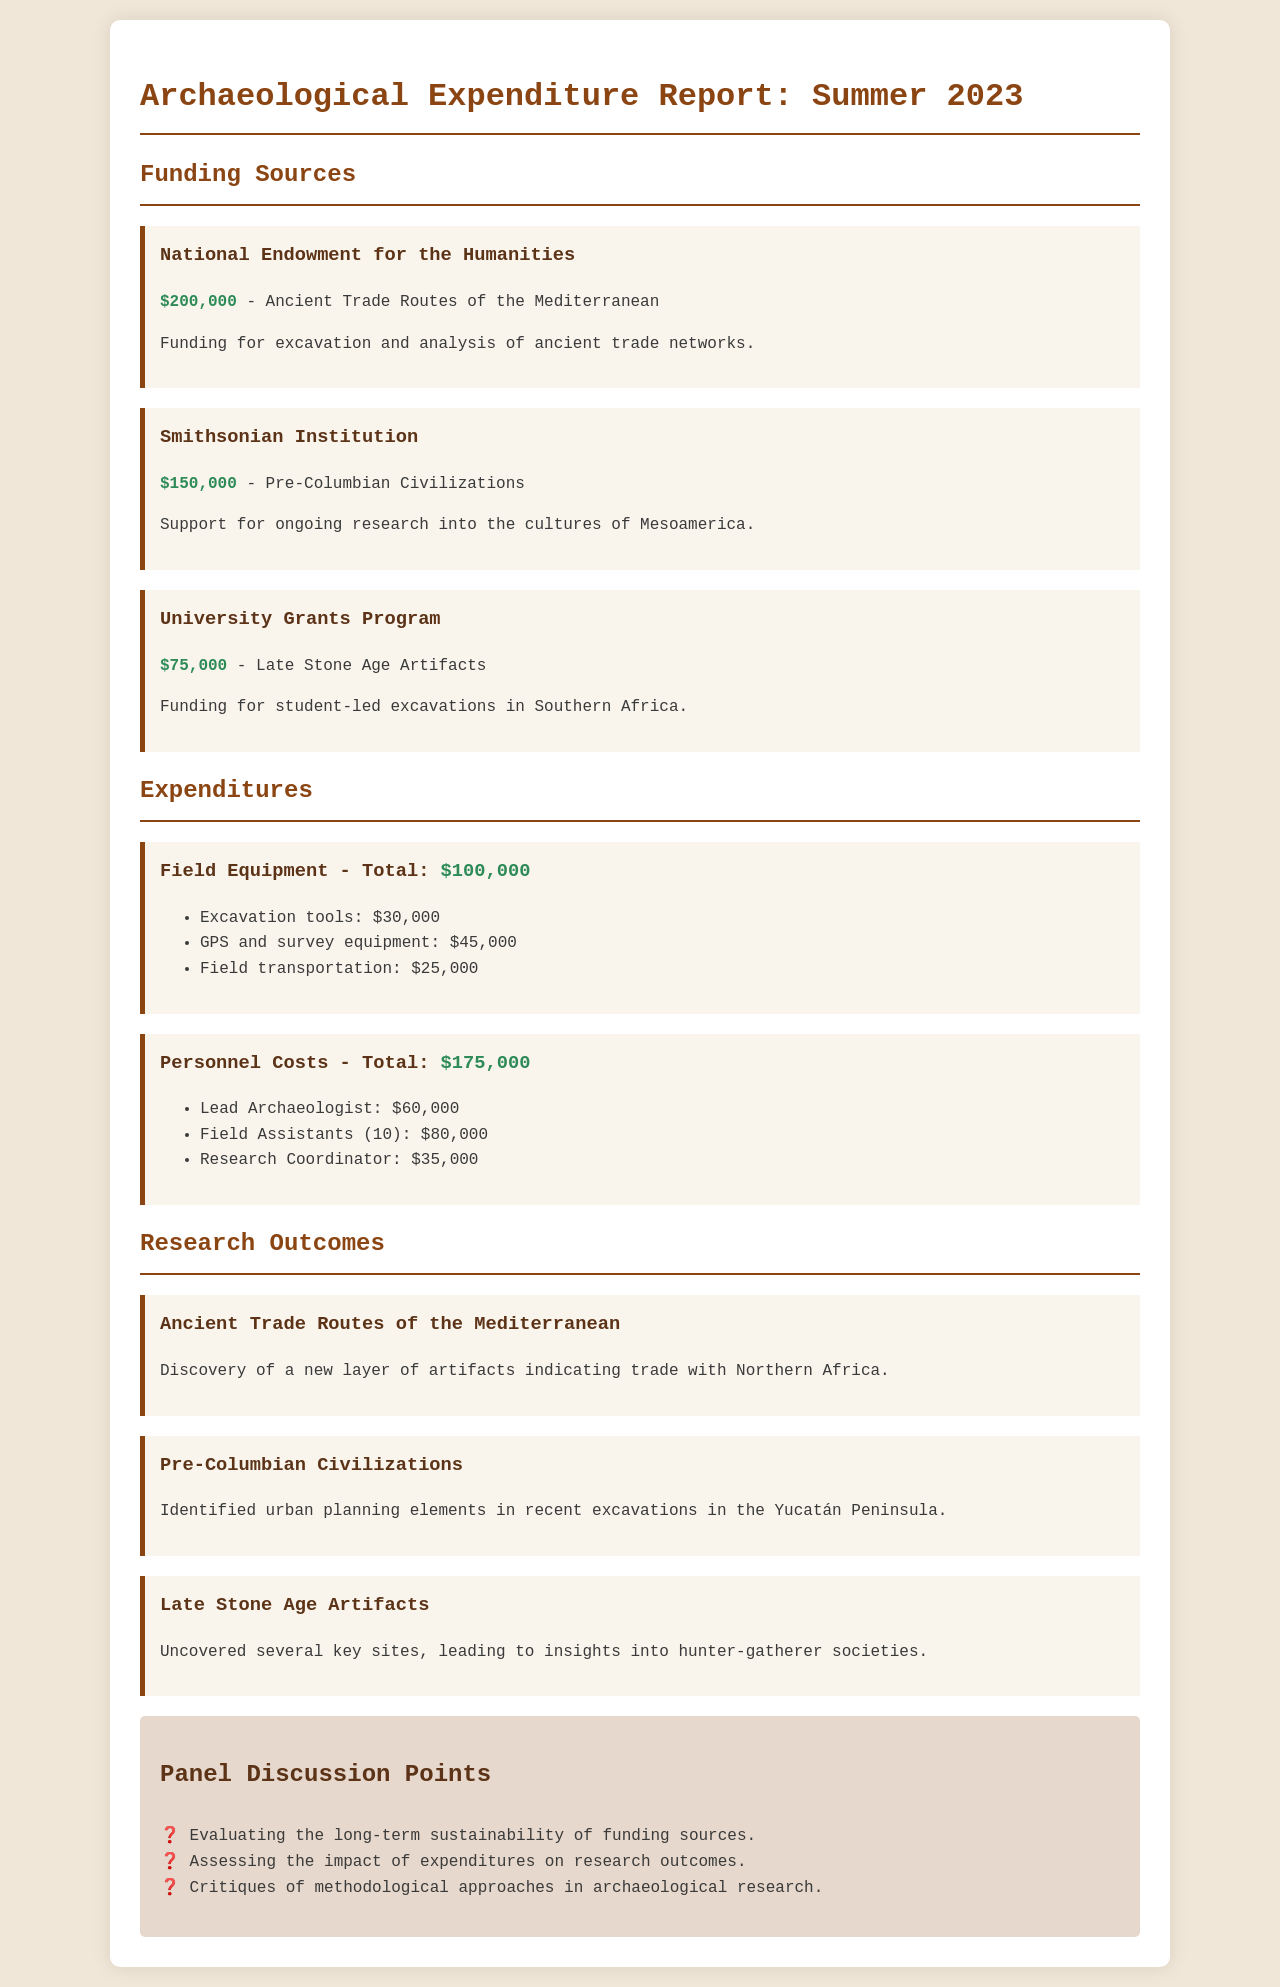What is the total funding from the National Endowment for the Humanities? The funding amount specified for the National Endowment for the Humanities is $200,000.
Answer: $200,000 How much was allocated for field equipment? The total allocated for field equipment is detailed in the expenditures section as $100,000.
Answer: $100,000 What project received funding from the Smithsonian Institution? The project titled "Pre-Columbian Civilizations" received funding from the Smithsonian Institution.
Answer: Pre-Columbian Civilizations What is the total expense for personnel costs? The total expense for personnel costs is specifically listed as $175,000 in the expenditures section.
Answer: $175,000 How many field assistants were employed? The document states that there were 10 field assistants employed, as mentioned under personnel costs.
Answer: 10 What key finding was reported in the "Ancient Trade Routes of the Mediterranean" project? The key finding reported indicates the discovery of a new layer of artifacts indicating trade with Northern Africa.
Answer: Trade with Northern Africa What is one of the panel discussion points mentioned? The document lists "Evaluating the long-term sustainability of funding sources" as a panel discussion point.
Answer: Evaluating the long-term sustainability of funding sources Which funding source provided the least amount of funding? The University Grants Program provided the least amount of funding, which is stated as $75,000.
Answer: $75,000 What aspect is assessed concerning the expenditures? The impact of expenditures on research outcomes is specifically assessed, as highlighted in the panel discussion points.
Answer: Impact of expenditures on research outcomes What was the budget for GPS and survey equipment? The budget allocated for GPS and survey equipment is listed as $45,000 in the expenditures section.
Answer: $45,000 